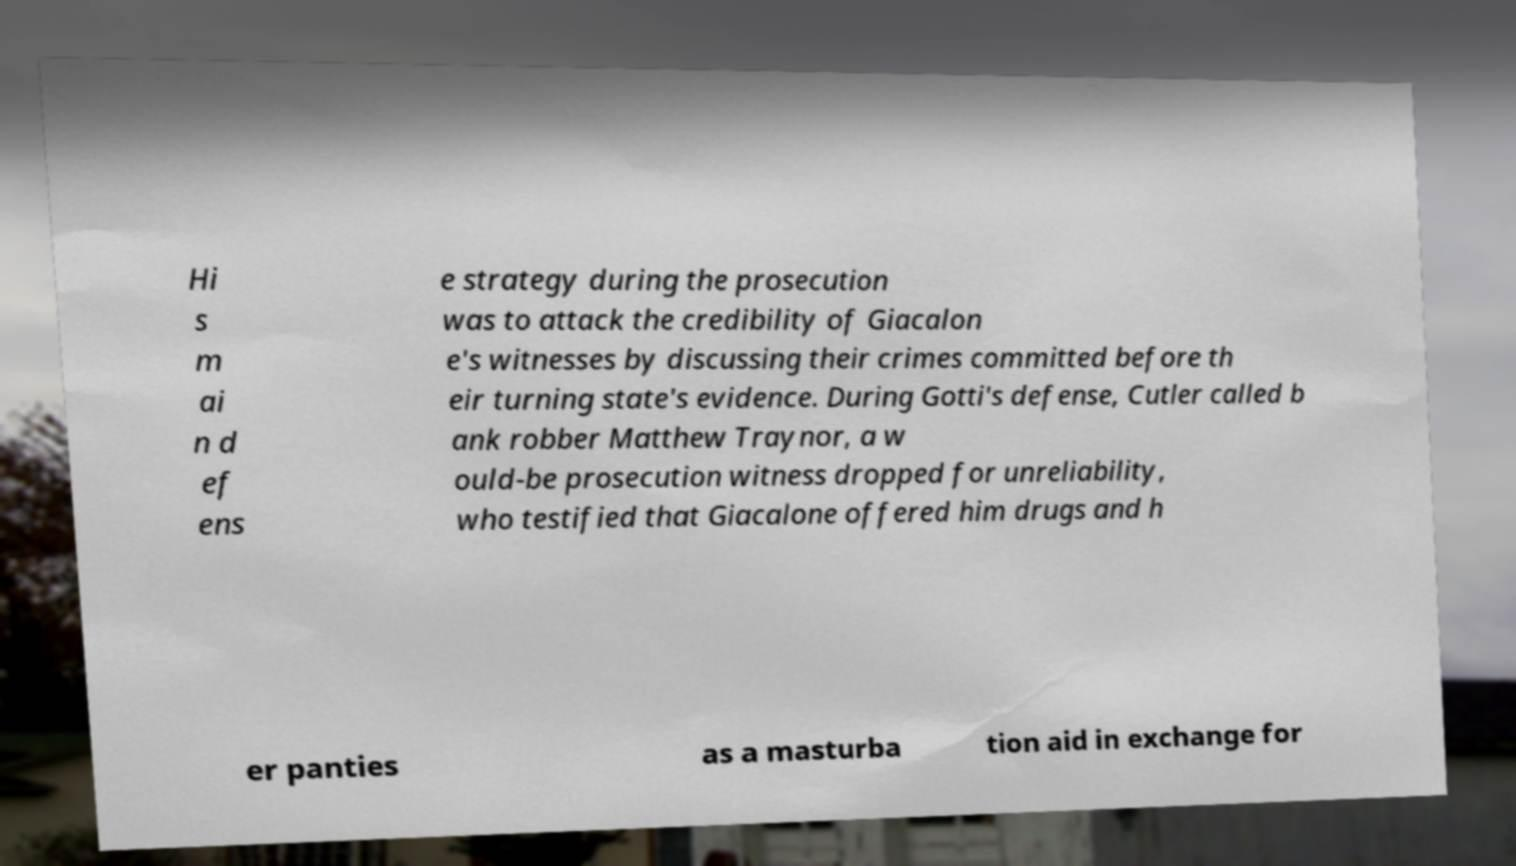Could you assist in decoding the text presented in this image and type it out clearly? Hi s m ai n d ef ens e strategy during the prosecution was to attack the credibility of Giacalon e's witnesses by discussing their crimes committed before th eir turning state's evidence. During Gotti's defense, Cutler called b ank robber Matthew Traynor, a w ould-be prosecution witness dropped for unreliability, who testified that Giacalone offered him drugs and h er panties as a masturba tion aid in exchange for 